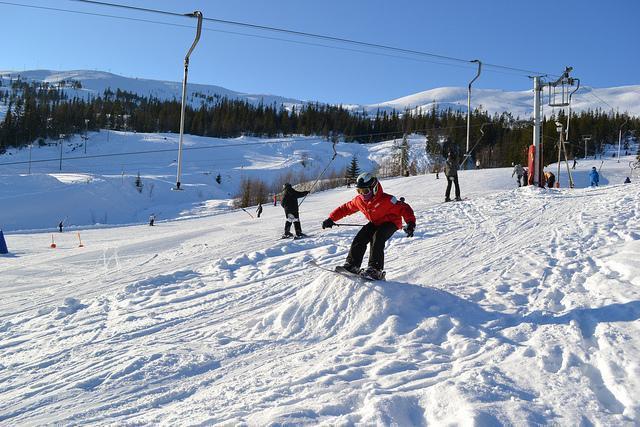After traversing over the jump what natural force will cause the boarder to return to the ground?
Make your selection from the four choices given to correctly answer the question.
Options: Gravity, inertia, fission, kinetic energy. Gravity. 